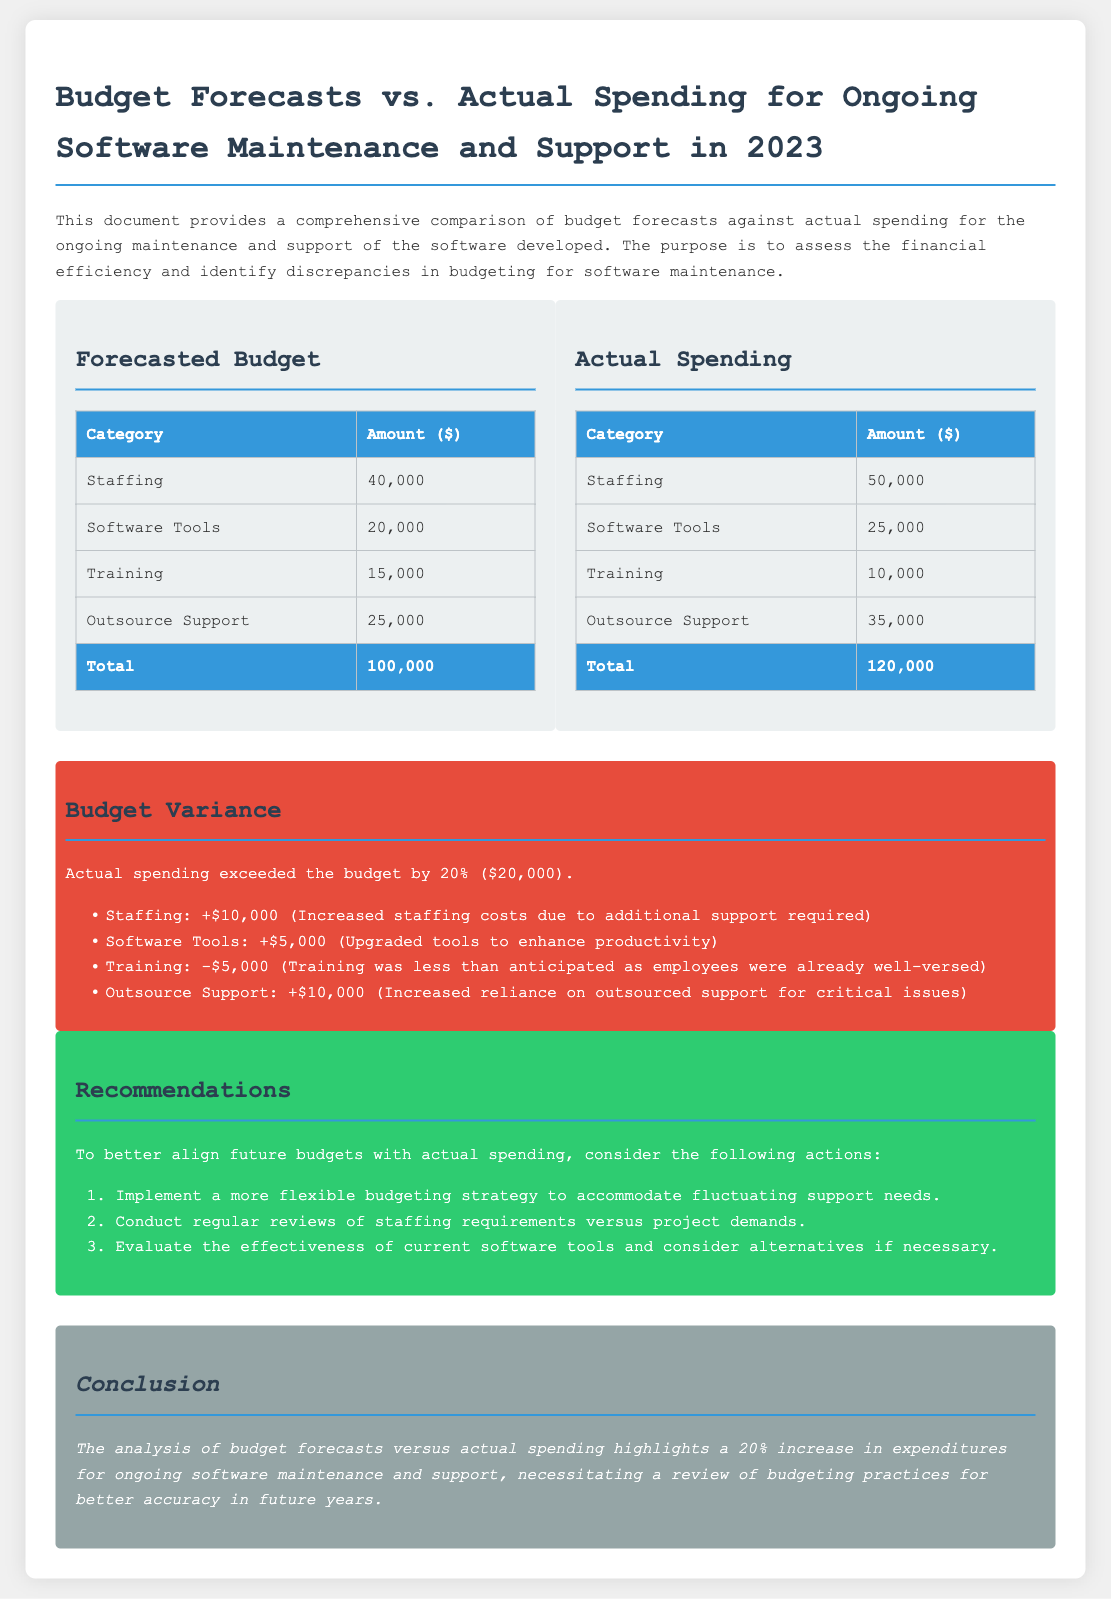What was the total forecasted budget? The forecasted budget total is clearly specified in the document as $100,000.
Answer: $100,000 What was the actual spending on software tools? The actual spending on software tools is listed in the table under actual spending as $25,000.
Answer: $25,000 How much did actual spending exceed the budget by? The document states that actual spending exceeded the budget by $20,000.
Answer: $20,000 What was the variance in staffing costs? The variance in staffing costs indicates an increase of $10,000, as mentioned in the budget variance section.
Answer: $10,000 What recommendation is given regarding software tools? One of the recommendations includes evaluating the effectiveness of current software tools.
Answer: Evaluate the effectiveness of current software tools What was the total actual spending? The total actual spending is summarized in the document as $120,000.
Answer: $120,000 How much less was spent on training compared to the forecast? The document specifies that training spending was $5,000 less than anticipated.
Answer: $5,000 What percentage increase does the document attribute to actual spending? The document states that the increase in expenditures for ongoing software maintenance is 20%.
Answer: 20% 